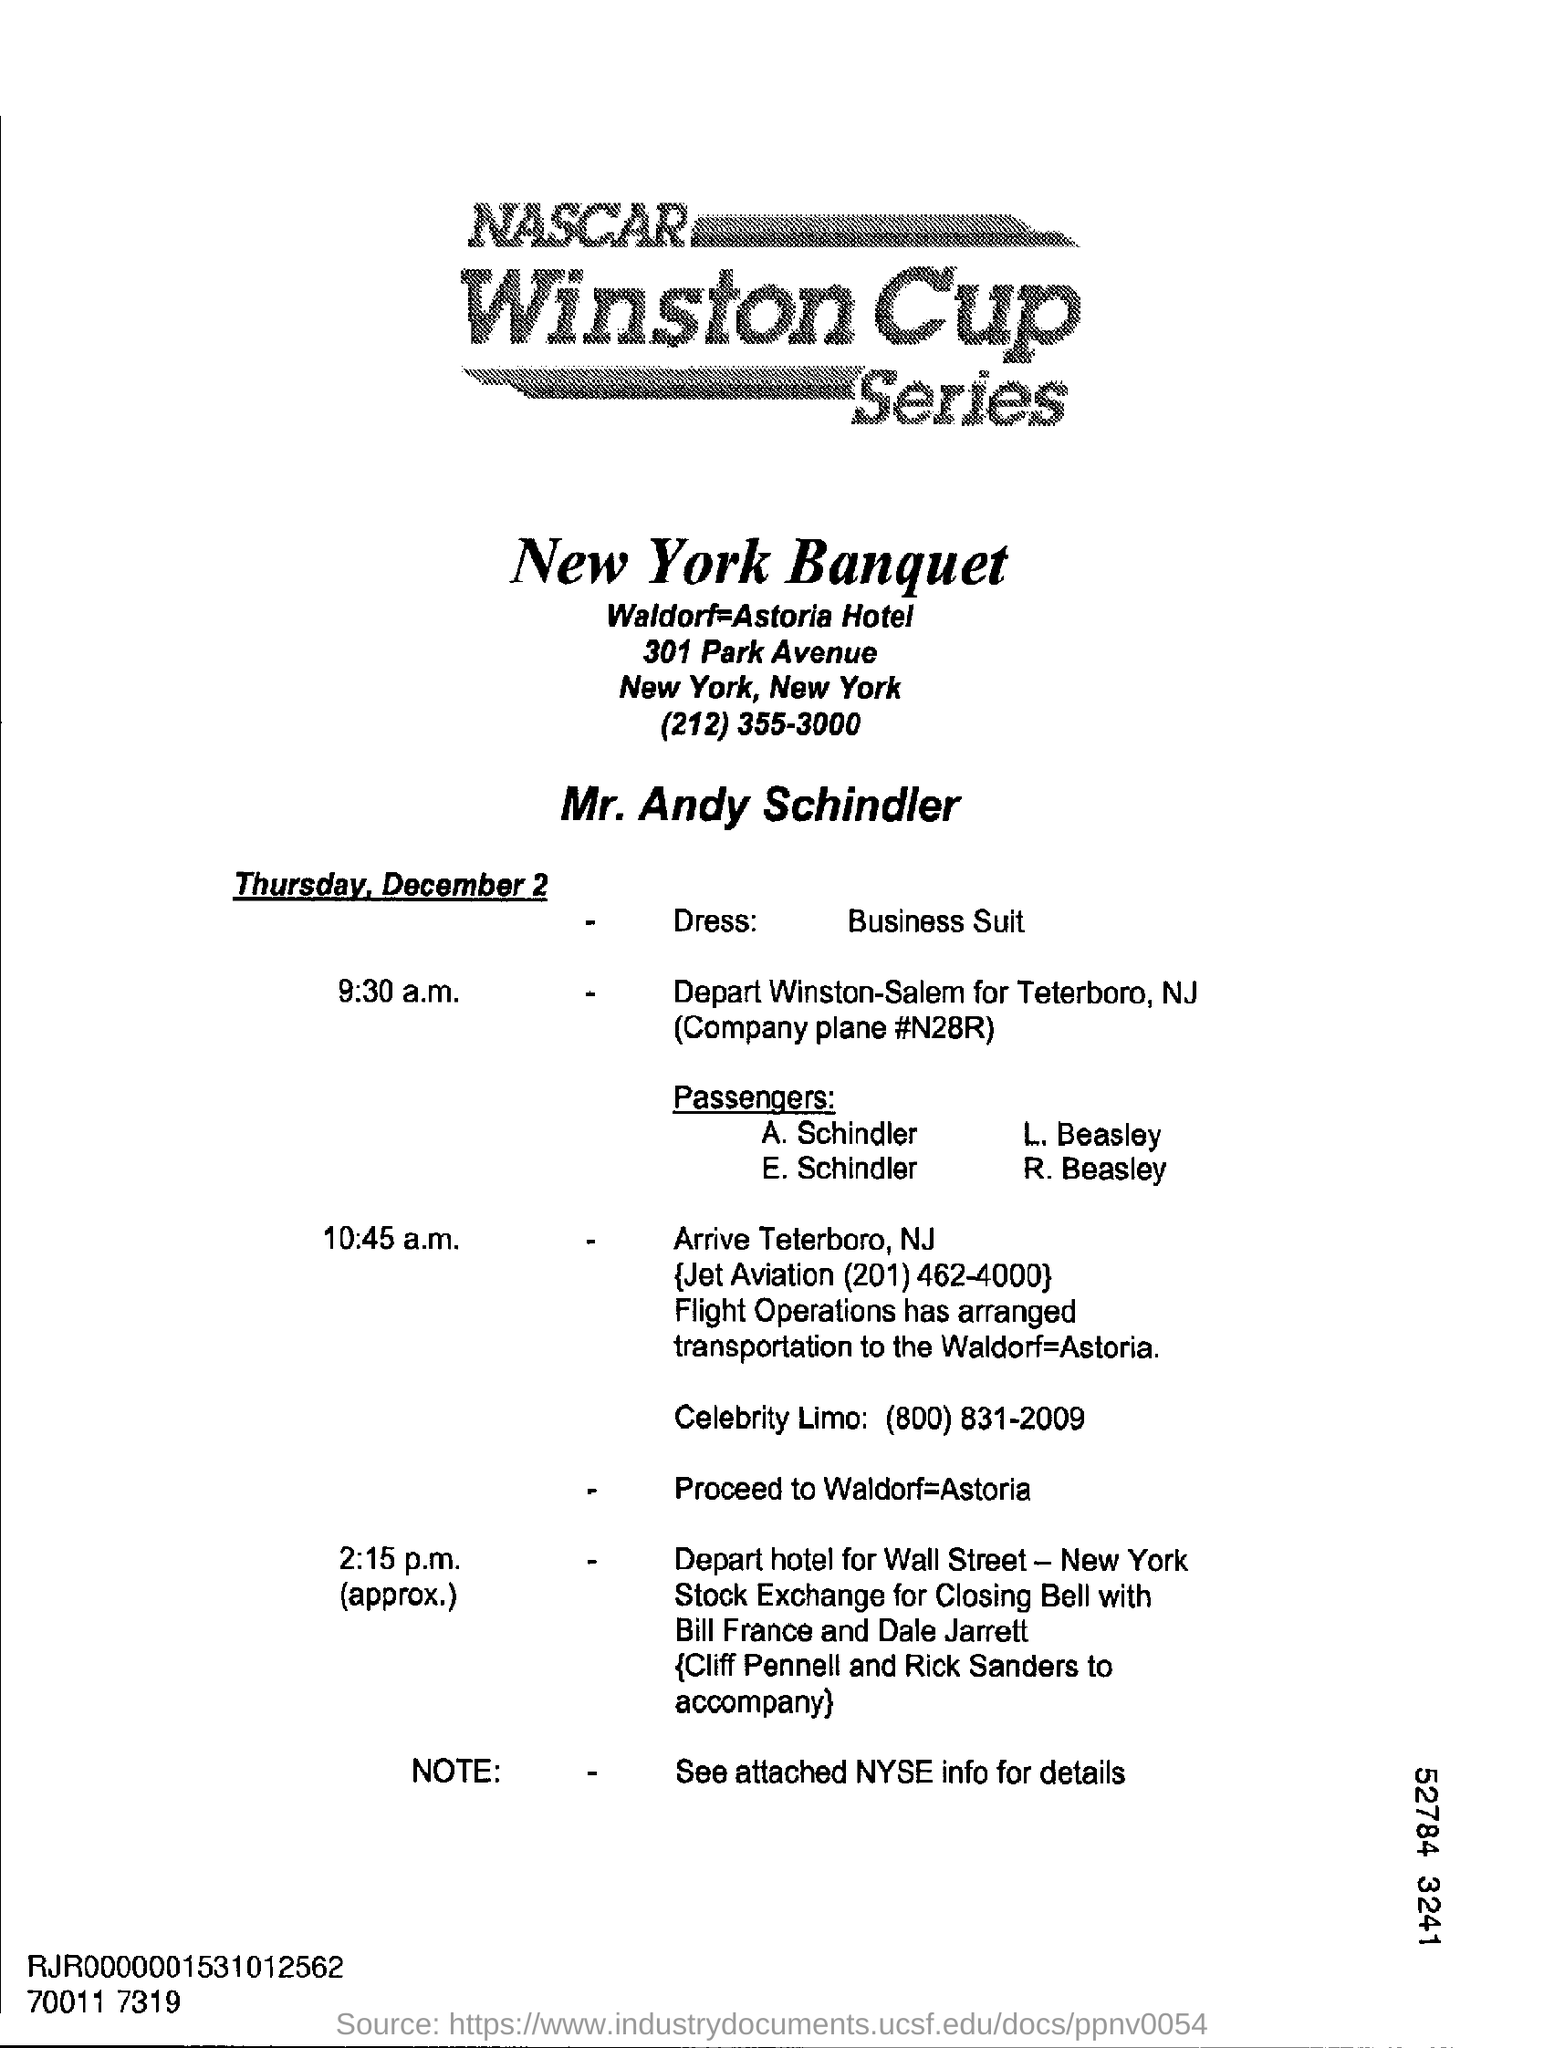What is the date mentioned?
Offer a very short reply. Thursday, December 2. What is the dress mentioned?
Provide a short and direct response. Business suit. 